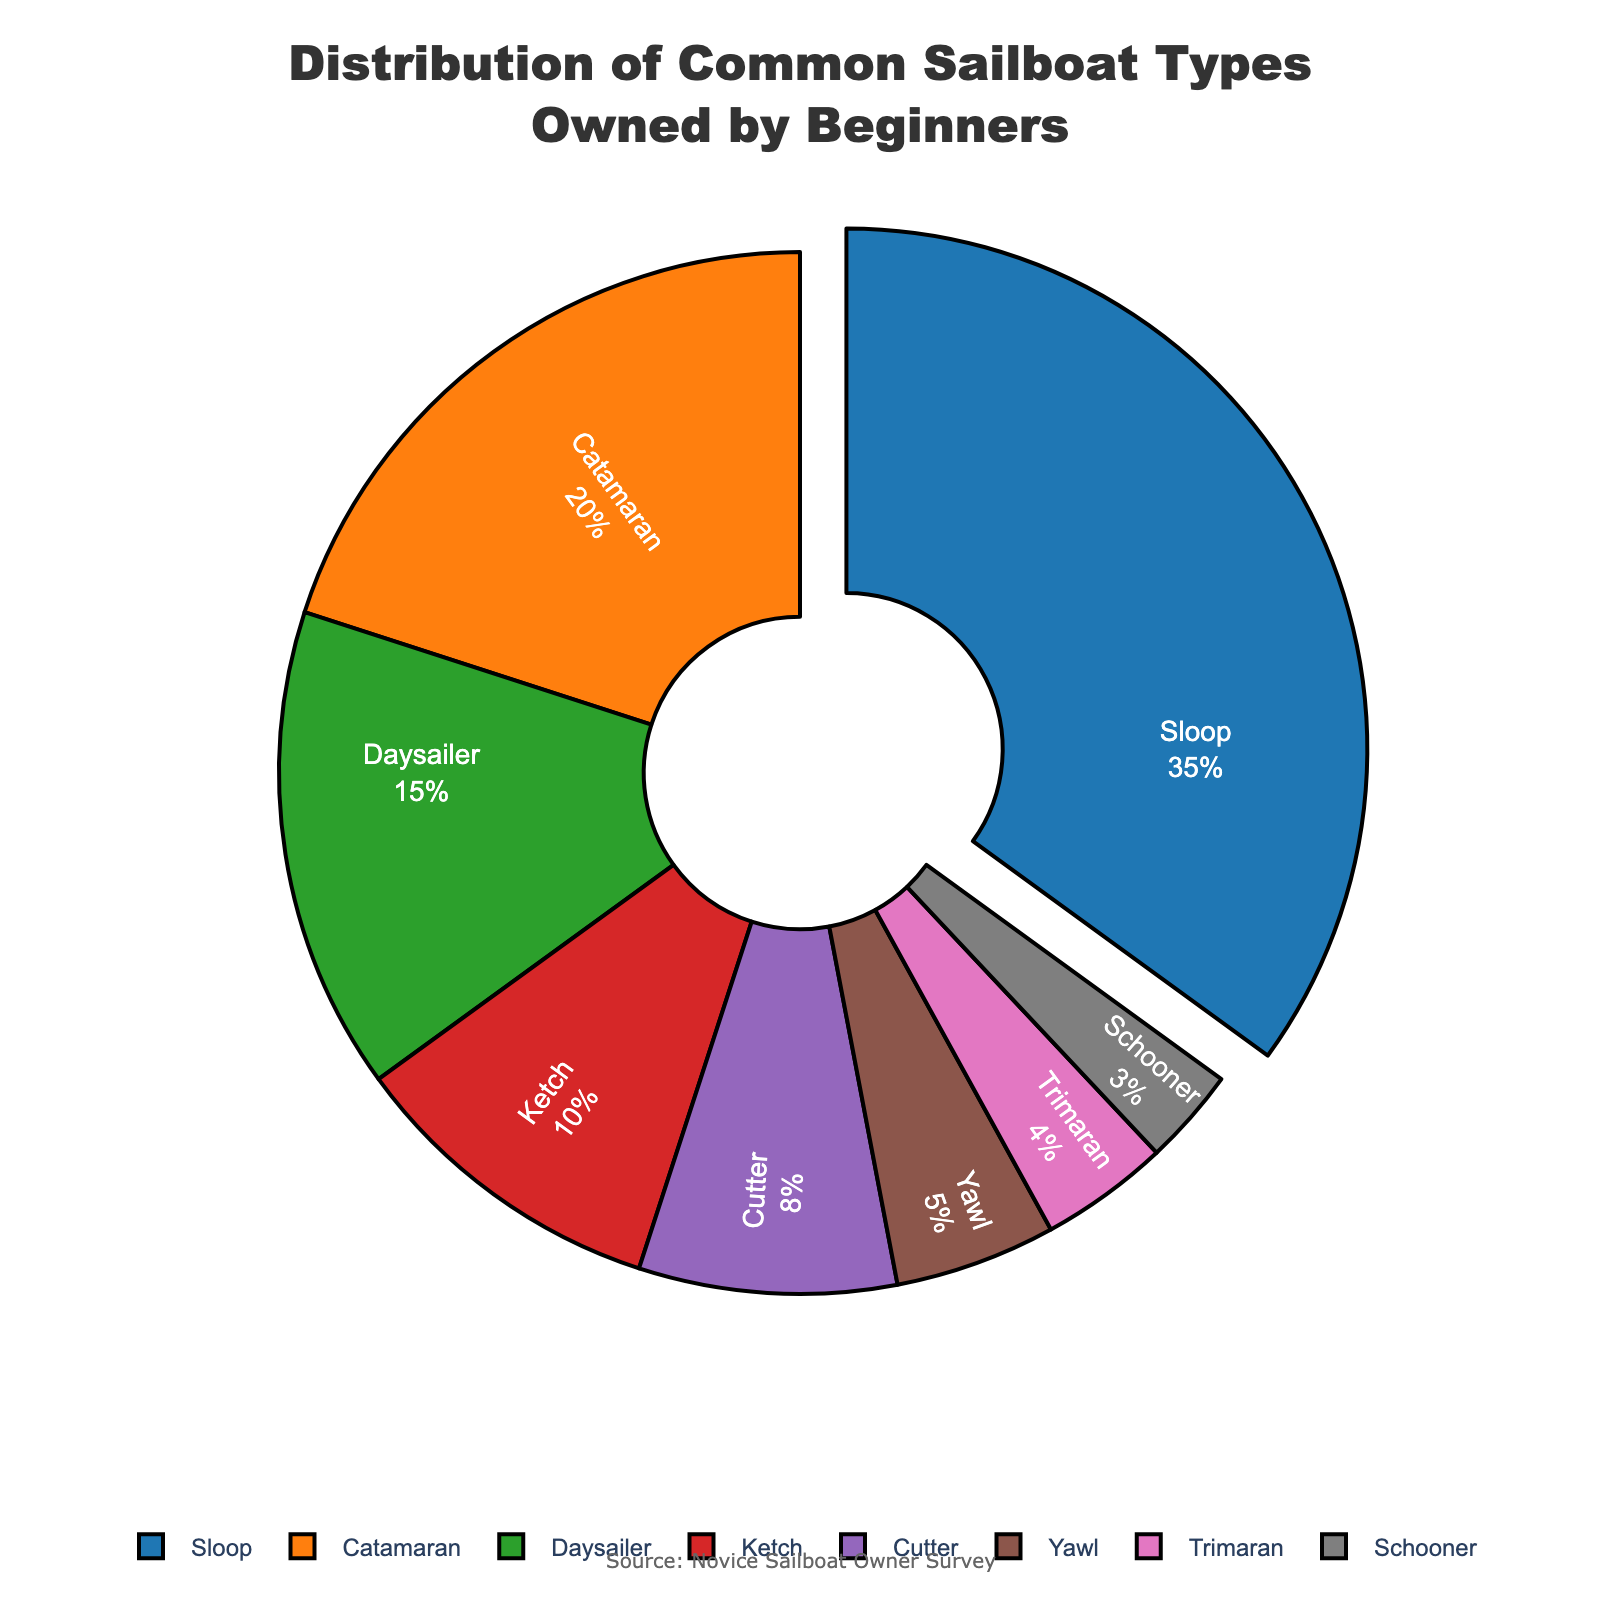Which boat type is the most commonly owned by beginners? The largest slice of the pie chart is for the Sloop, which is pulled outward and labeled as having the highest percentage.
Answer: Sloop How much more common are Sloops compared to Yawls? The percentages for Sloops and Yawls are 35% and 5% respectively. The difference is 35% - 5%.
Answer: 30% What's the combined percentage of Sloops, Catamarans, and Daysailers? Add the percentages for Sloops (35%), Catamarans (20%), and Daysailers (15%): 35% + 20% + 15% = 70%.
Answer: 70% Which boat type makes up the smallest percentage of the beginner-owned sailboats? The smallest slice of the pie chart corresponds to Schooners, which is labeled as 3%.
Answer: Schooner Are Catamarans as common as Ketches and Cutters combined? Catamarans have a percentage of 20%. Ketches have 10% and Cutters have 8%. The combined percentage of Ketches and Cutters is 10% + 8% = 18%. 18% is less than 20%.
Answer: No What's the percentage difference between the most and least common boat types? The most common is Sloop at 35%, and the least common is Schooner at 3%. The difference is 35% - 3%.
Answer: 32% Which boat types' percentages add up to 25%? The smaller boat types are Yawl (5%), Trimaran (4%), and Schooner (3%). Yawl and Trimaran add up to 5% + 4% = 9%. Adding Schooner, we get 9% + 3% = 12%. Adding Cutter (8%) next, we get 12% + 8% = 20%, and finally adding Ketch (10%) next, we get 20% + 10% = 30%, which exceeds 25%. So the correct combination is Yawl, Trimaran, Cutter, and Schooner. 5% + 4% + 8% + 3% = 20%.
Answer: Yawl, Trimaran, Cutter, Schooner (20%) Among Daysailer, Ketch, and Cutter, which is the least common? From the pie chart, the percentages for Daysailer, Ketch, and Cutter are 15%, 10%, and 8% respectively. The lowest percentage among these three is for Cutter.
Answer: Cutter How many boat types have a percentage greater than or equal to 10%? From the pie chart, the boat types with percentages 10% or higher are Sloop (35%), Catamaran (20%), Daysailer (15%), and Ketch (10%).
Answer: 4 By how much does the percentage of Sloops exceed the combined percentage of Yawls and Trimarans? The percentage for Sloops is 35%. The combined percentage for Yawls (5%) and Trimarans (4%) is 5% + 4% = 9%. The difference is 35% - 9%.
Answer: 26% 